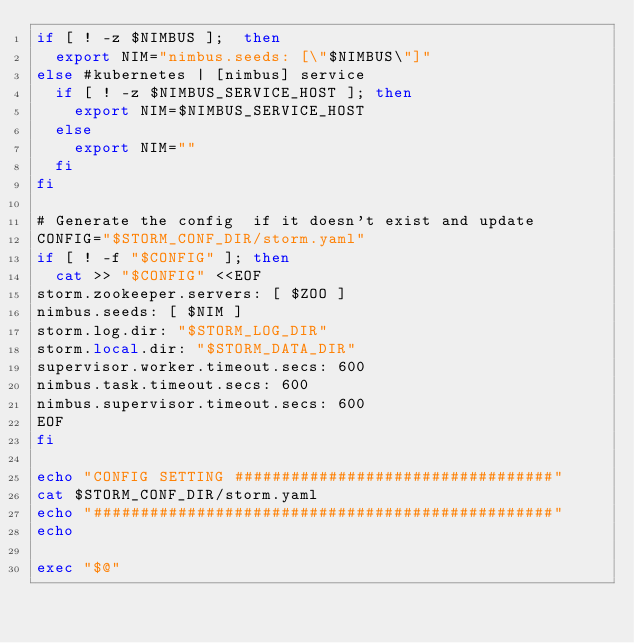Convert code to text. <code><loc_0><loc_0><loc_500><loc_500><_Bash_>if [ ! -z $NIMBUS ];  then
  export NIM="nimbus.seeds: [\"$NIMBUS\"]"
else #kubernetes | [nimbus] service
  if [ ! -z $NIMBUS_SERVICE_HOST ]; then
    export NIM=$NIMBUS_SERVICE_HOST
  else
    export NIM=""
  fi
fi

# Generate the config  if it doesn't exist and update
CONFIG="$STORM_CONF_DIR/storm.yaml"
if [ ! -f "$CONFIG" ]; then
  cat >> "$CONFIG" <<EOF
storm.zookeeper.servers: [ $ZOO ]
nimbus.seeds: [ $NIM ]
storm.log.dir: "$STORM_LOG_DIR"
storm.local.dir: "$STORM_DATA_DIR"
supervisor.worker.timeout.secs: 600
nimbus.task.timeout.secs: 600
nimbus.supervisor.timeout.secs: 600
EOF
fi

echo "CONFIG SETTING ##################################"
cat $STORM_CONF_DIR/storm.yaml
echo "#################################################"
echo

exec "$@"
</code> 